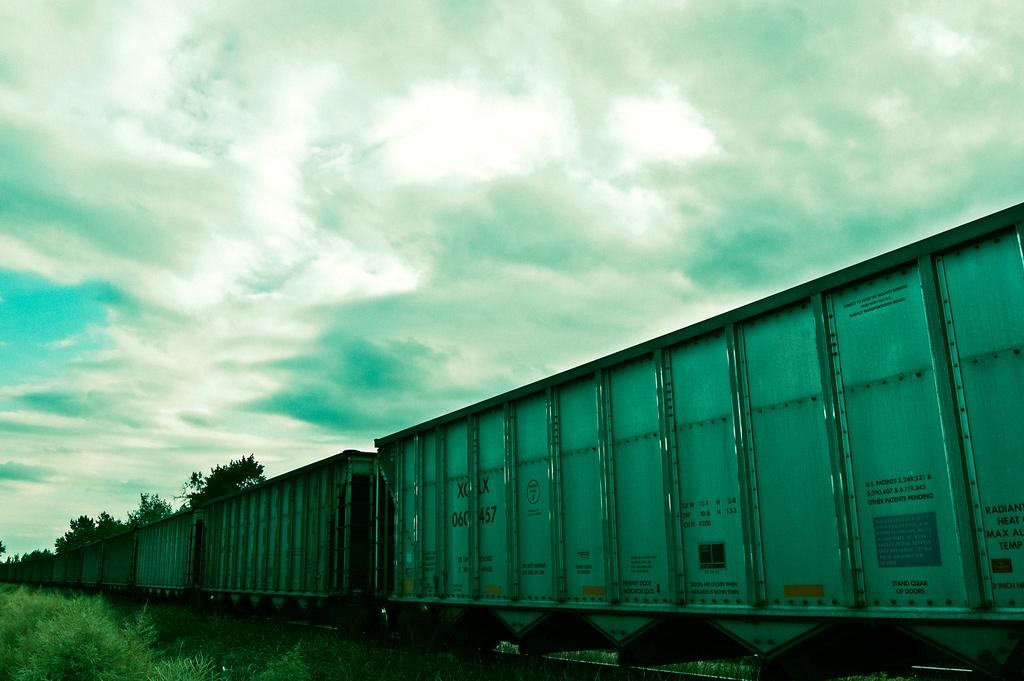What type of train is in the image? There is a goods train in the image. Where is the train located? The train is on a railway track. What can be seen on either side of the railway track? There are plants on either side of the railway track. What is visible at the top of the image? The sky is visible at the top of the image. What can be observed in the sky? Clouds are present in the sky. What type of wine is being served to the kitty in the image? There is no wine or kitty present in the image; it features a goods train on a railway track with plants and clouds in the sky. 